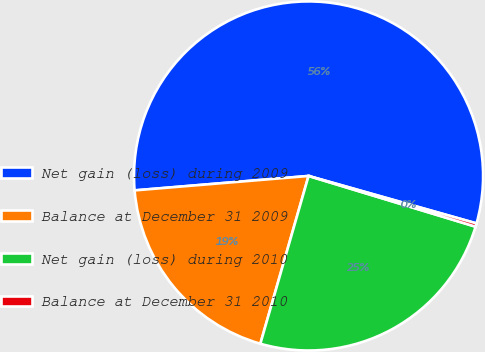Convert chart to OTSL. <chart><loc_0><loc_0><loc_500><loc_500><pie_chart><fcel>Net gain (loss) during 2009<fcel>Balance at December 31 2009<fcel>Net gain (loss) during 2010<fcel>Balance at December 31 2010<nl><fcel>55.7%<fcel>19.23%<fcel>24.76%<fcel>0.31%<nl></chart> 